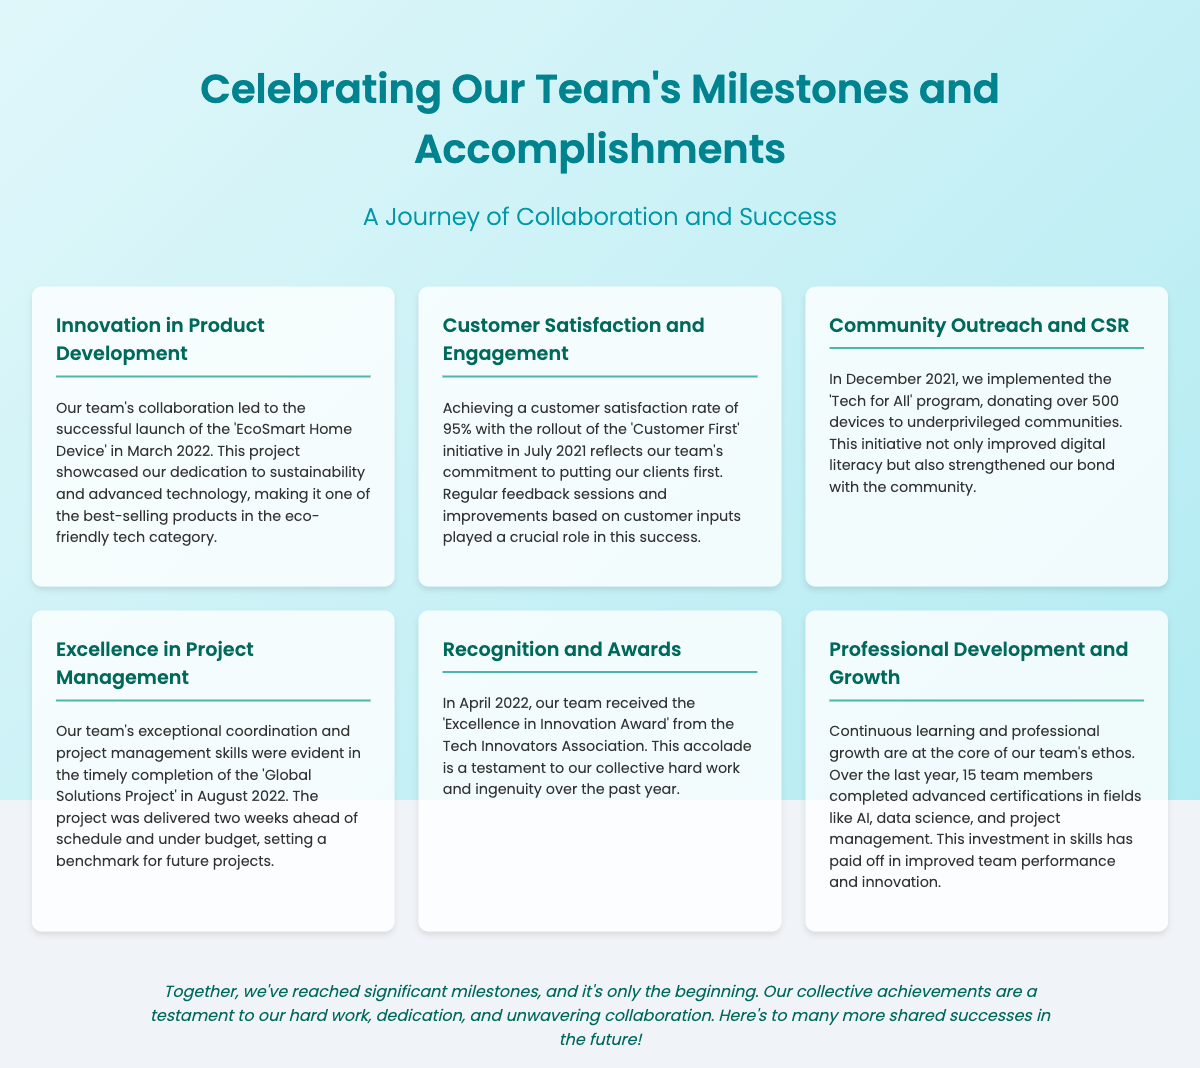What product was launched in March 2022? The section on Innovation in Product Development mentions the 'EcoSmart Home Device' as the successful launch by the team in March 2022.
Answer: EcoSmart Home Device What was the customer satisfaction rate achieved with the 'Customer First' initiative? The content provides the customer satisfaction rate as 95% achieved through the initiative rolled out in July 2021.
Answer: 95% When was the 'Tech for All' program implemented? The document states that the implementation of the 'Tech for All' program occurred in December 2021.
Answer: December 2021 How many devices were donated through the 'Tech for All' program? The section on Community Outreach indicates that over 500 devices were donated to underprivileged communities.
Answer: Over 500 devices What award did the team receive in April 2022? The Recognition and Awards section mentions the 'Excellence in Innovation Award' received in April 2022.
Answer: Excellence in Innovation Award How many team members completed advanced certifications in the last year? The Professional Development and Growth section indicates that 15 team members achieved advanced certifications.
Answer: 15 team members What was notable about the 'Global Solutions Project' completion? The Excellence in Project Management section highlights that it was completed two weeks ahead of schedule and under budget, which was a significant achievement.
Answer: Two weeks ahead of schedule and under budget What is the overarching theme of the poster? The header of the document presents the theme as 'Celebrating Our Team's Milestones and Accomplishments.'
Answer: Celebrating Our Team's Milestones and Accomplishments How does the closing statement summarize the team's achievements? The closing states that the collective achievements are a testament to hard work, dedication, and collaboration, underscoring the importance of these values.
Answer: Testament to hard work, dedication, and collaboration 